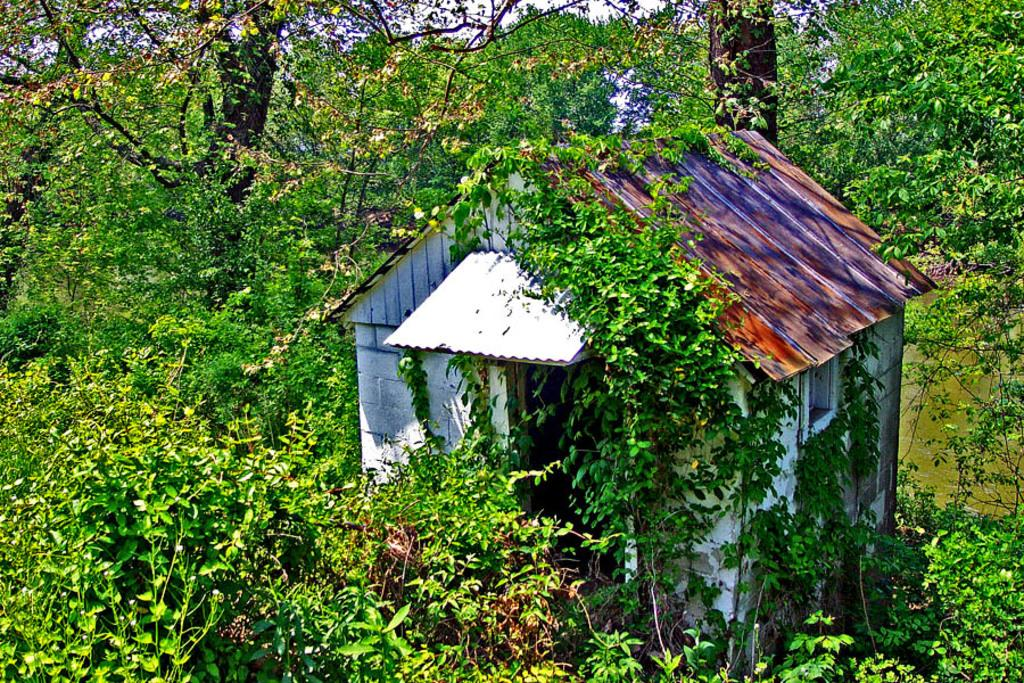What is the main structure visible in the image? There is a house in the image. What type of natural vegetation is present around the house? There are trees around the house in the image. What type of print can be seen on the pencil in the image? There is no pencil present in the image, and therefore no print can be observed. What is the base material of the house in the image? The base material of the house cannot be determined from the image alone. 